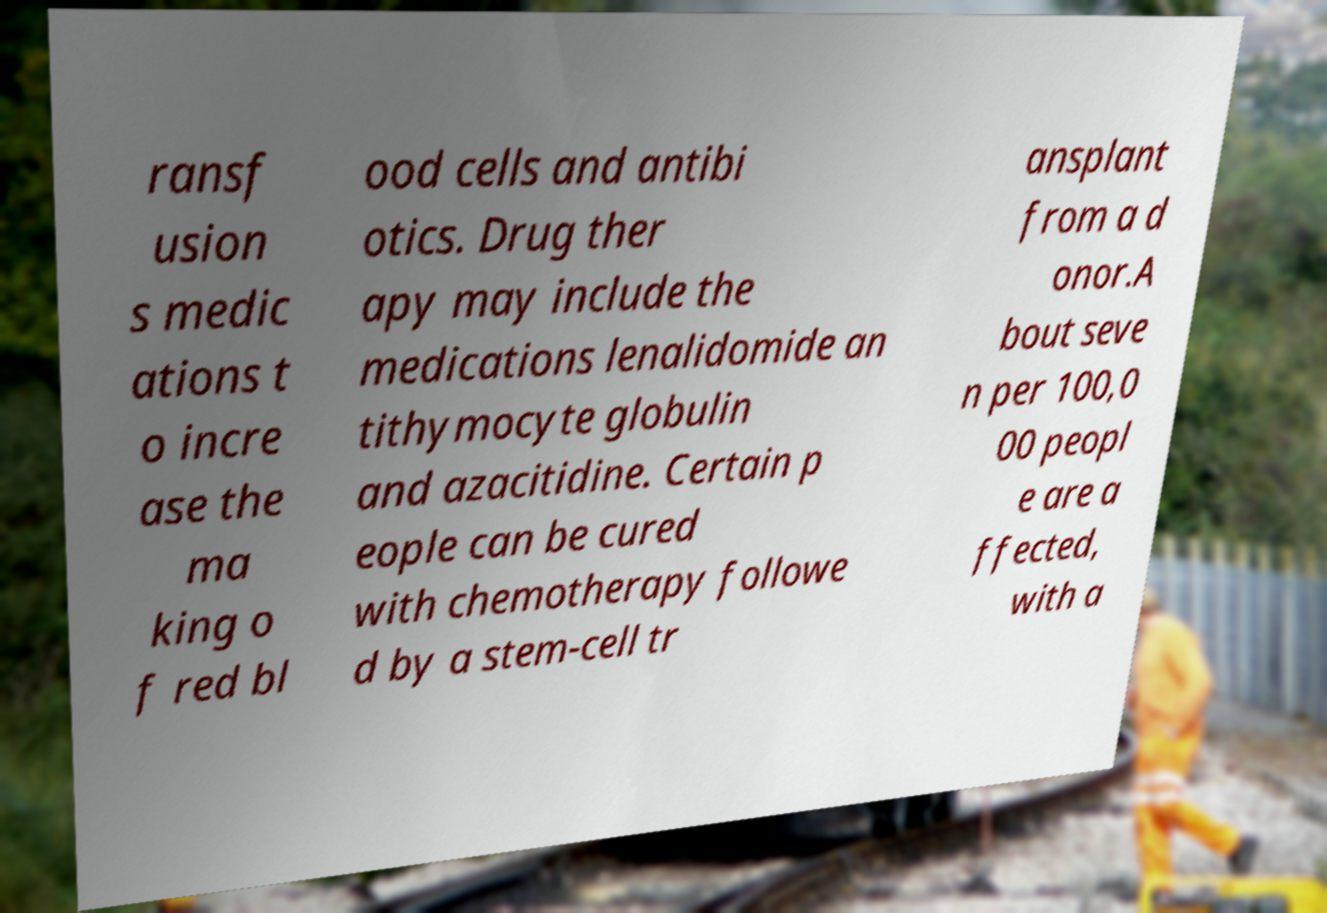For documentation purposes, I need the text within this image transcribed. Could you provide that? ransf usion s medic ations t o incre ase the ma king o f red bl ood cells and antibi otics. Drug ther apy may include the medications lenalidomide an tithymocyte globulin and azacitidine. Certain p eople can be cured with chemotherapy followe d by a stem-cell tr ansplant from a d onor.A bout seve n per 100,0 00 peopl e are a ffected, with a 